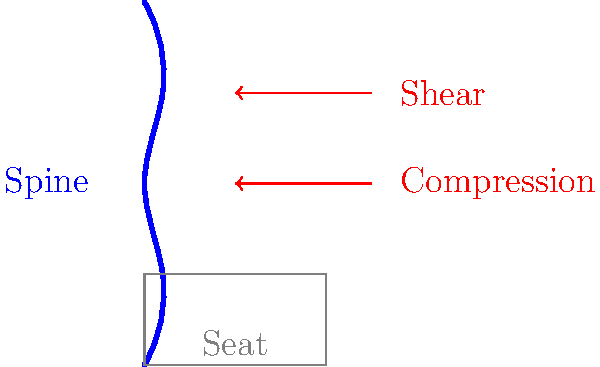In the context of prolonged sitting in patrol cars, which type of force acting on the spine is most likely to contribute to the development of lower back pain and potential disc herniation? To answer this question, let's consider the forces acting on the spine during prolonged sitting:

1. Compression force: This vertical force acts downward on the spine due to the weight of the upper body and head. During sitting, this force is distributed along the spine and through the pelvis to the seat.

2. Shear force: This horizontal force acts perpendicular to the spine's axis. In a seated position, especially with poor posture, there can be increased shear forces on the lower spine.

3. Prolonged sitting effects:
   a) Reduced lumbar lordosis (flattening of the lower back curve)
   b) Increased intradiscal pressure
   c) Decreased nutrient supply to intervertebral discs

4. Impact on spinal structures:
   a) Compression forces can lead to gradual disc degeneration over time
   b) Shear forces, particularly when combined with poor posture, can place excessive stress on the posterior elements of the spine, including the facet joints and ligaments

5. Risk for disc herniation:
   While both compression and shear forces contribute to spinal stress, shear forces are more likely to cause acute injury to the intervertebral discs, potentially leading to herniation.

6. Relevance to patrol car sitting:
   The design of many patrol cars, combined with the need to frequently twist or turn to access equipment, can increase shear forces on the spine.

Given these factors, while both compression and shear forces play a role in spinal health, shear forces are more directly linked to the risk of disc herniation and acute lower back pain in the context of prolonged sitting in patrol cars.
Answer: Shear force 